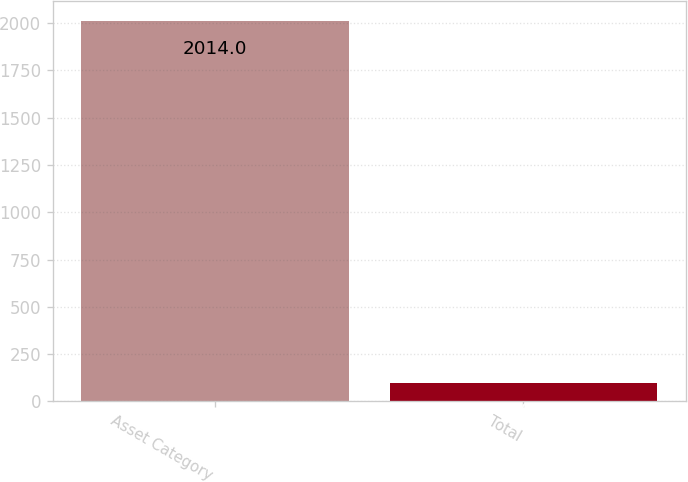Convert chart. <chart><loc_0><loc_0><loc_500><loc_500><bar_chart><fcel>Asset Category<fcel>Total<nl><fcel>2014<fcel>100<nl></chart> 